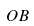Convert formula to latex. <formula><loc_0><loc_0><loc_500><loc_500>O B</formula> 